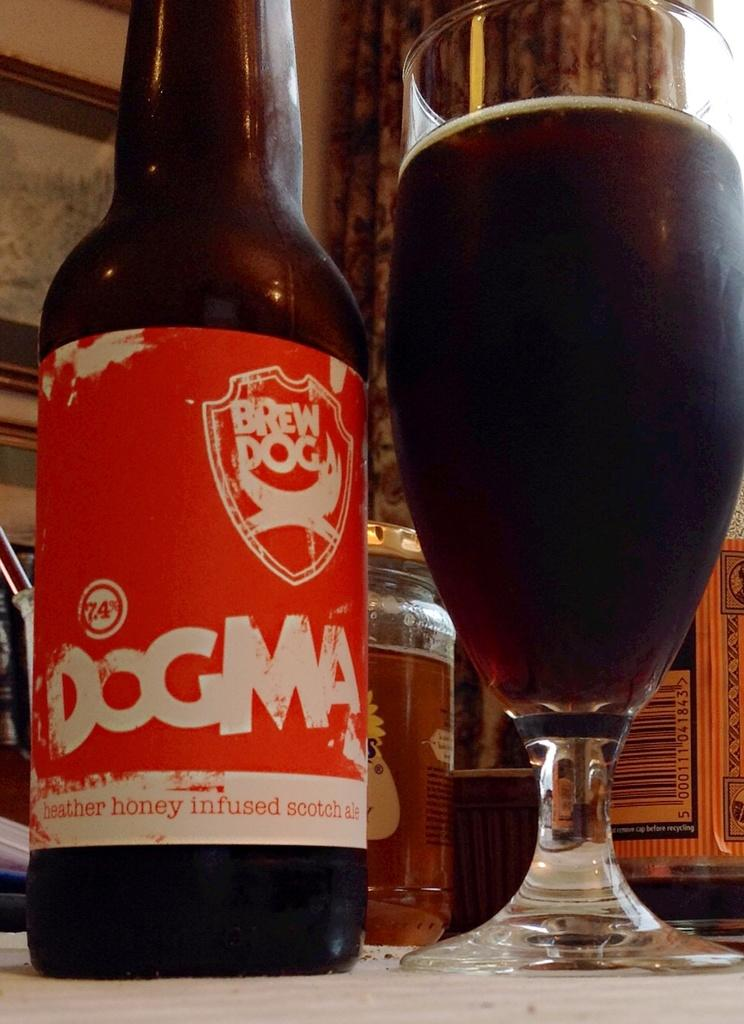<image>
Offer a succinct explanation of the picture presented. A bottle and glass of Dogma Brew beer sitting together. 